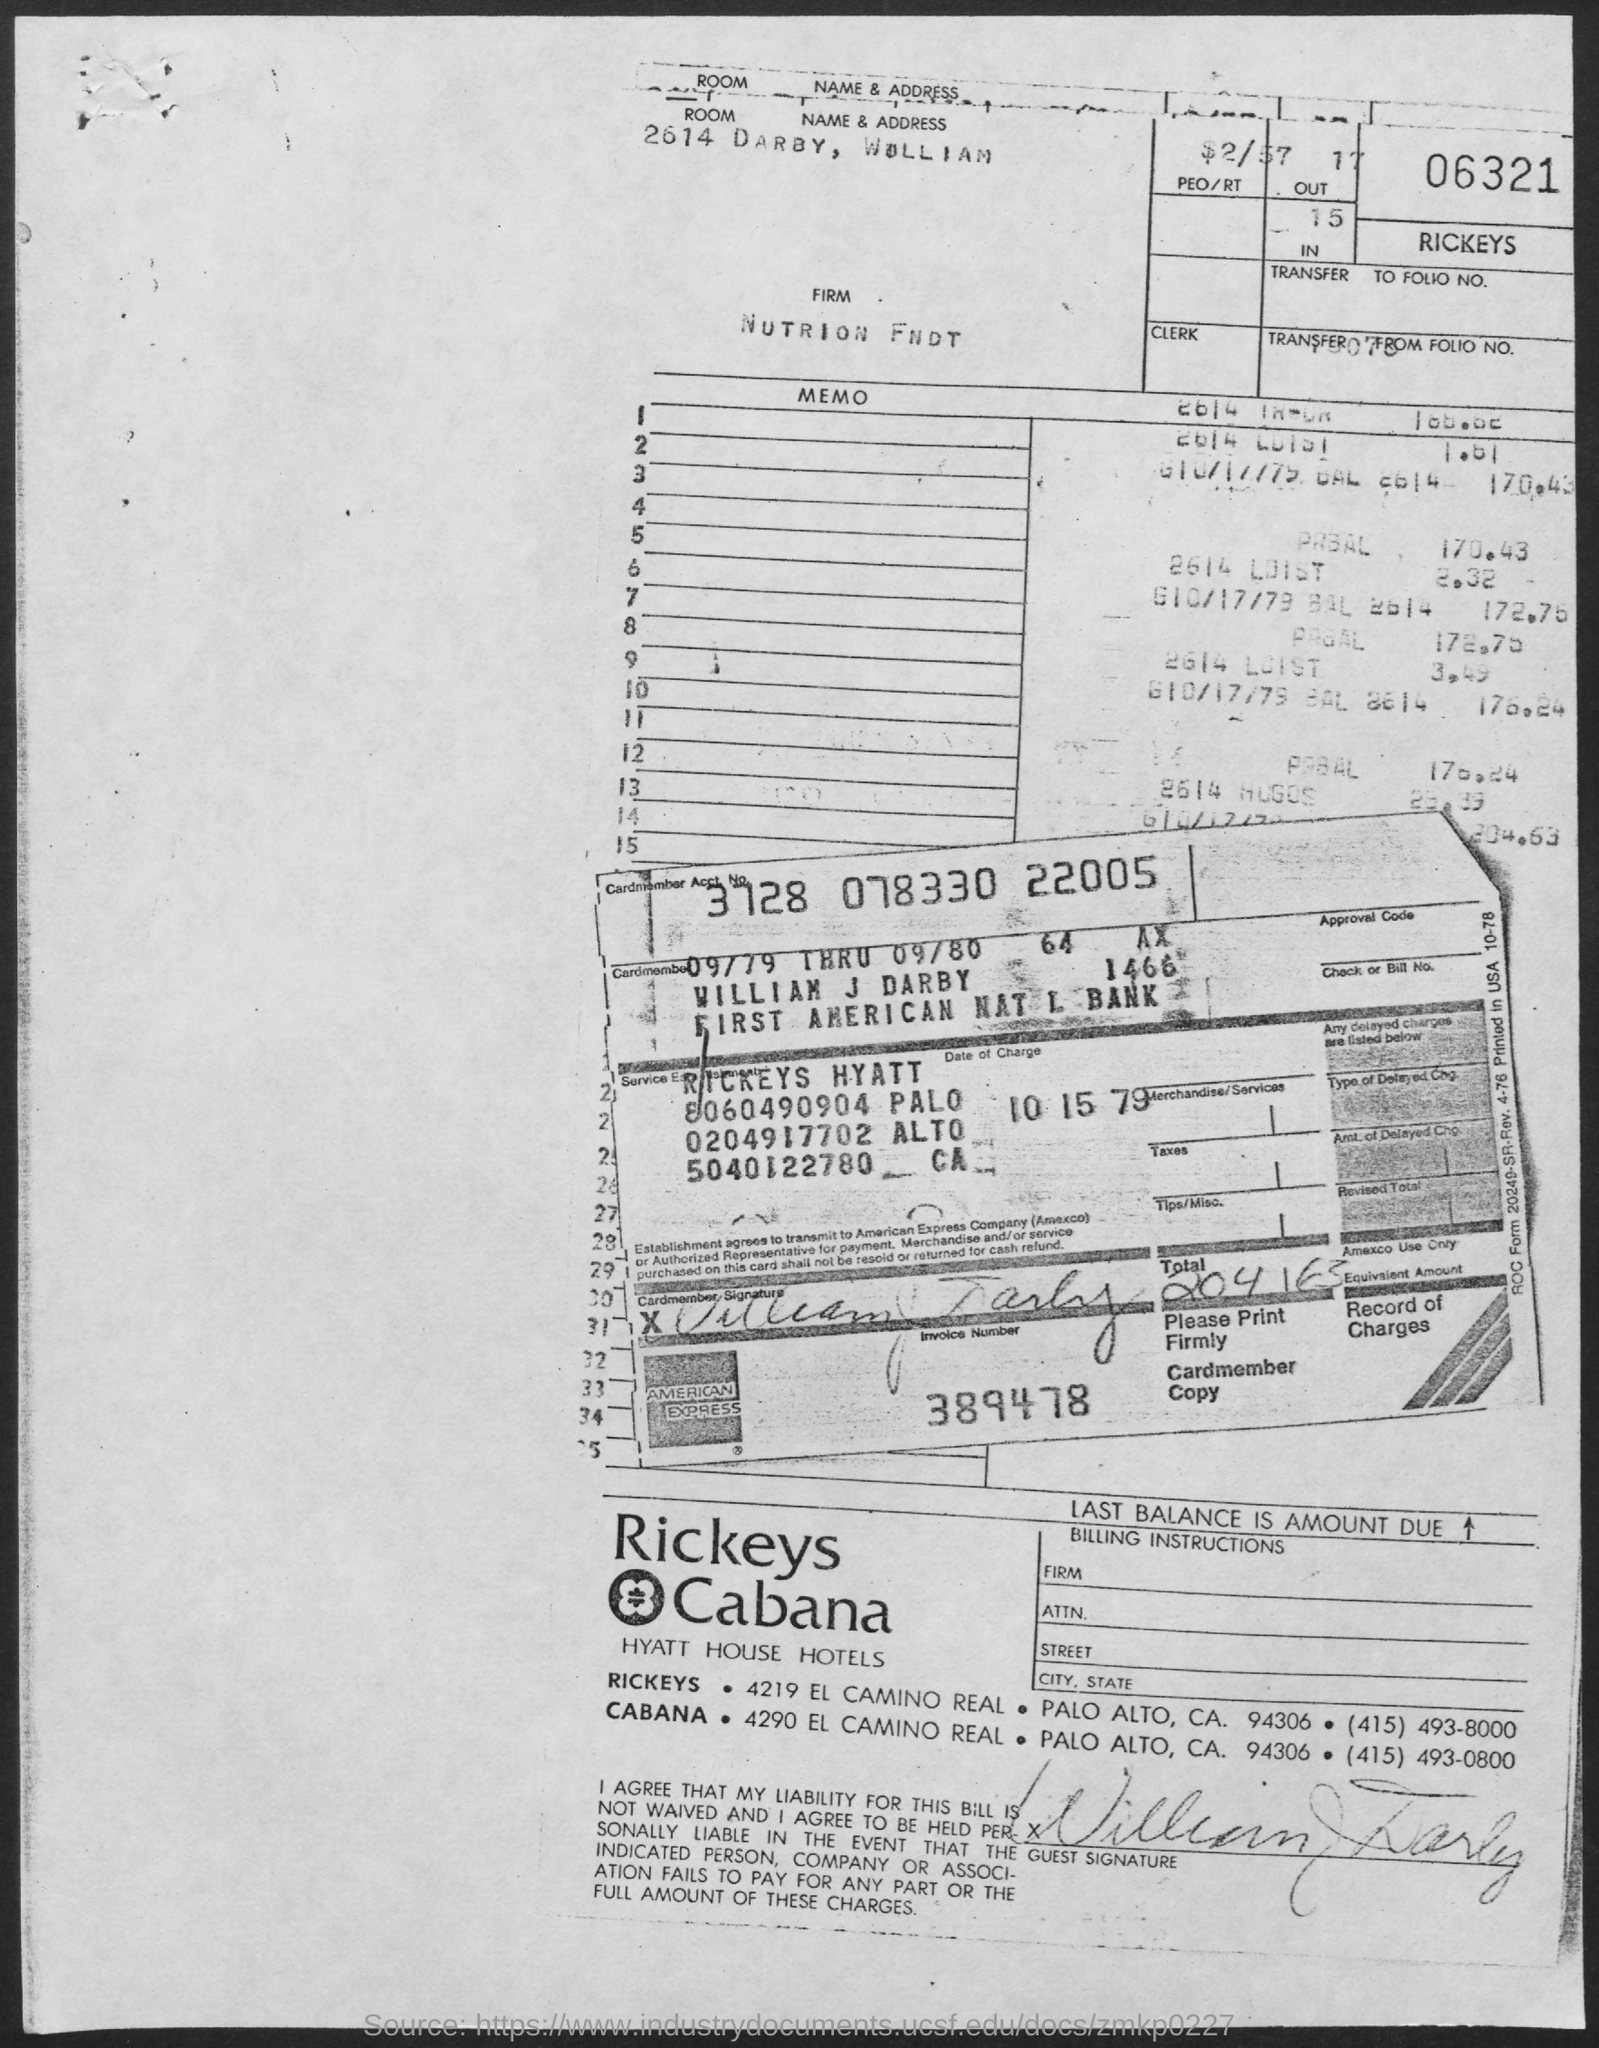What is the Room number ?
Provide a short and direct response. 2614. What number is written above the word "RICKEYS" in the right top?
Ensure brevity in your answer.  06321. What is the Firm name?
Your response must be concise. NUTRION FNDT. What is the account number of the Cardmember ?
Your answer should be very brief. 3728 078330 22005. What is the full name of the Cardmember?
Offer a terse response. William J Darby. What is the Invoice Number?
Offer a very short reply. 389478. What is the Date of Charge?
Offer a very short reply. 10 15 79. What is the contact number of CABANA ?
Ensure brevity in your answer.  (415) 493-0800. 